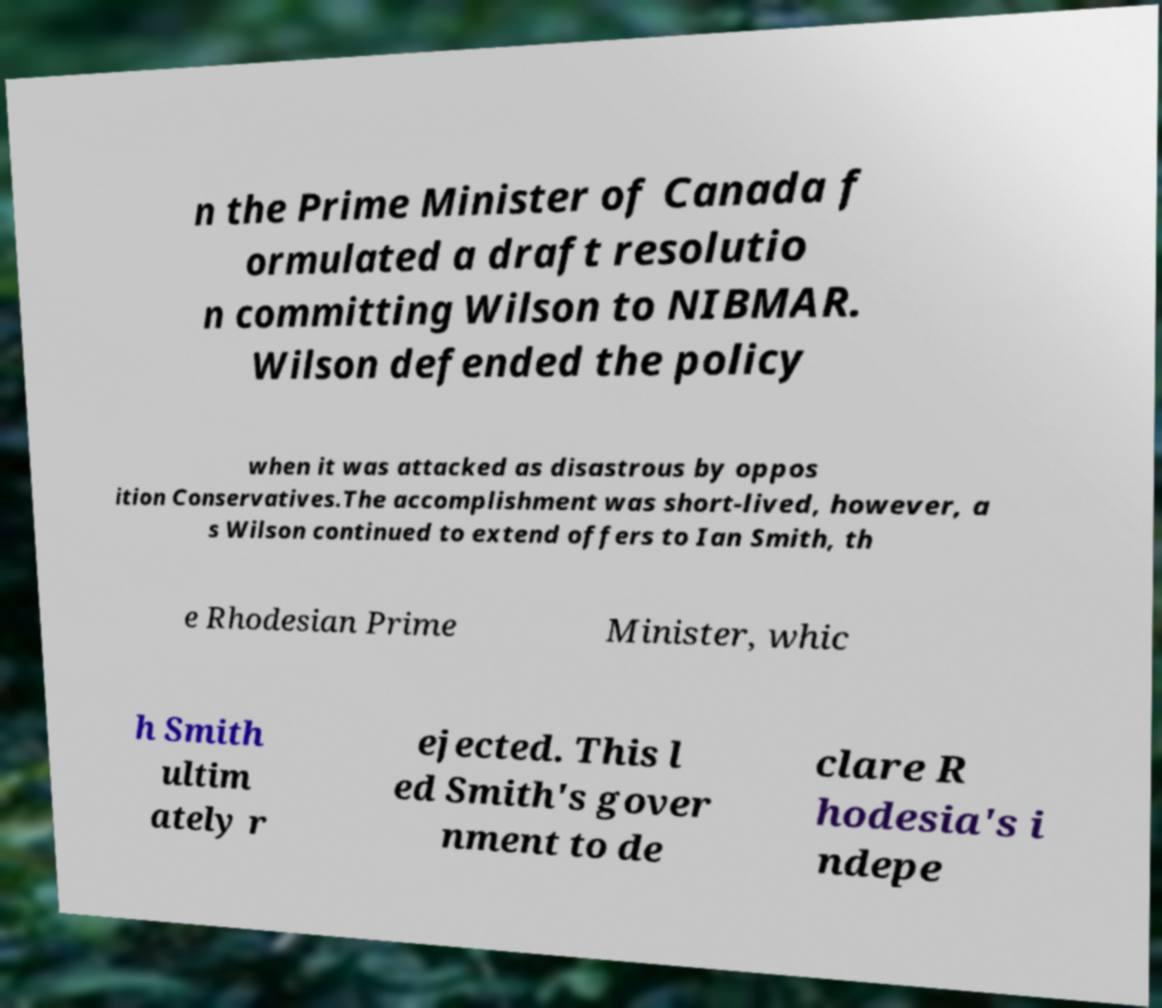Please read and relay the text visible in this image. What does it say? n the Prime Minister of Canada f ormulated a draft resolutio n committing Wilson to NIBMAR. Wilson defended the policy when it was attacked as disastrous by oppos ition Conservatives.The accomplishment was short-lived, however, a s Wilson continued to extend offers to Ian Smith, th e Rhodesian Prime Minister, whic h Smith ultim ately r ejected. This l ed Smith's gover nment to de clare R hodesia's i ndepe 